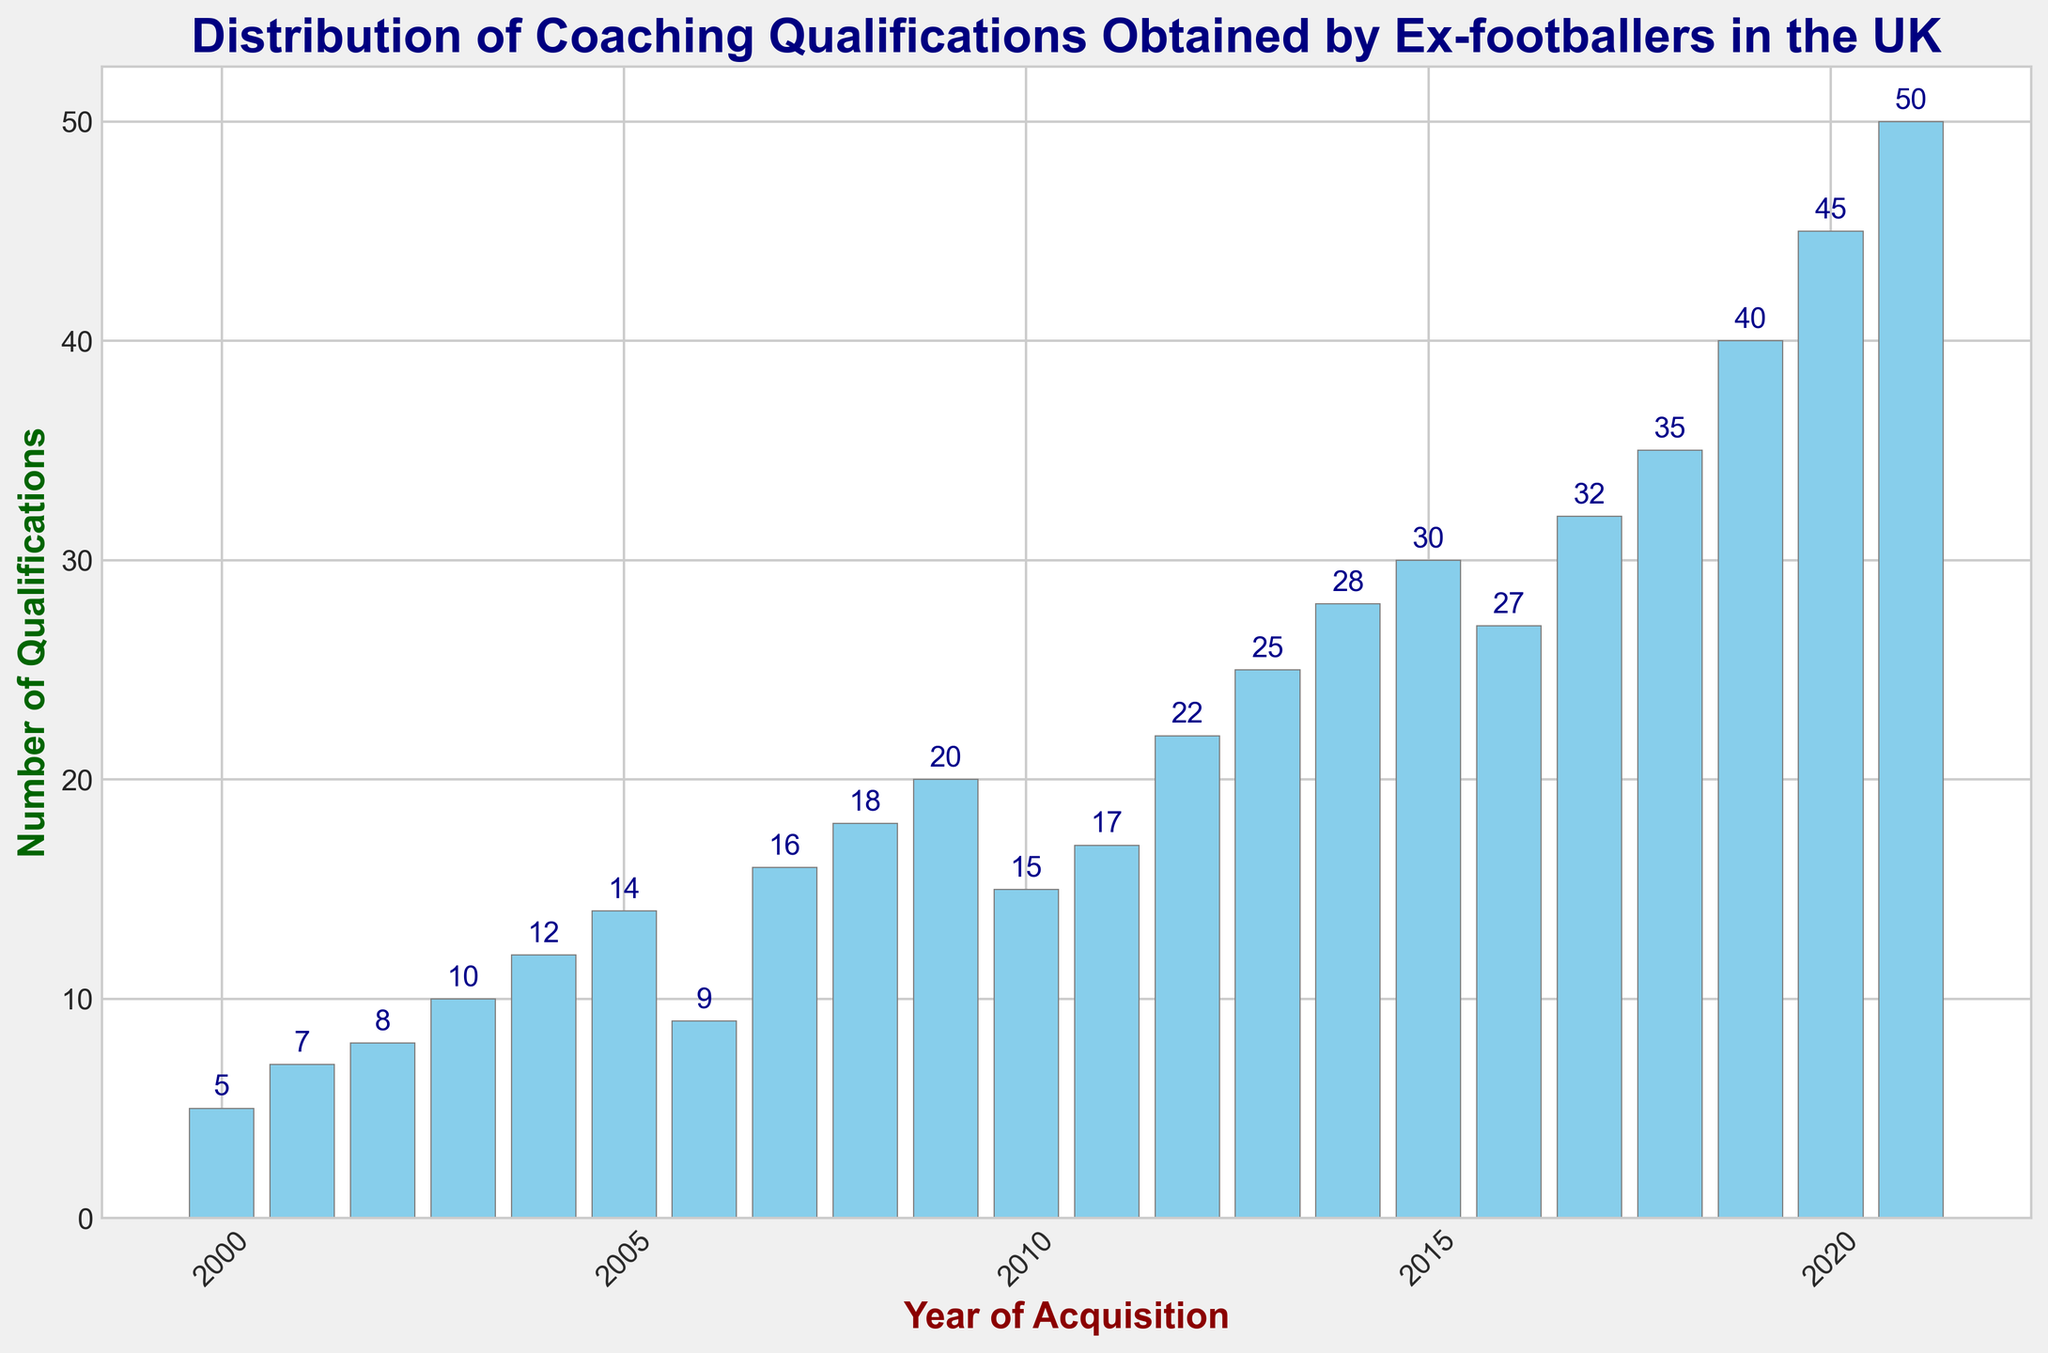What is the total number of coaching qualifications obtained from 2010 to 2020? Sum the number of qualifications from 2010 to 2020: 15 + 17 + 22 + 25 + 28 + 30 + 27 + 32 + 35 + 40 + 45 = 316
Answer: 316 Which year saw the highest number of coaching qualifications obtained? Examine the heights of all bars and identify the year with the tallest bar, which is 2021 with 50 qualifications
Answer: 2021 How does the number of qualifications in 2010 compare to that in 2019? Compare the heights of the bars for 2010 (15 qualifications) and 2019 (40 qualifications); 40 > 15
Answer: 2019 has more What is the average number of coaching qualifications obtained per year between 2000 and 2005? Calculate the average from 2000 to 2005: (5 + 7 + 8 + 10 + 12 + 14) / 6 = 56 / 6 ≈ 9.33
Answer: ≈ 9.33 Which year experienced the largest increase in the number of qualifications compared to the previous year? Calculate the year-over-year changes: 
2001-2000 = 2,
2002-2001 = 1,
2003-2002 = 2,
2004-2003 = 2,
2005-2004 = 2,
2006-2005 = -5,
2007-2006 = 7,
2008-2007 = 2,
2009-2008 = 2,
2010-2009 = -5,
2011-2010 = 2,
2012-2011 = 5,
2013-2012 = 3,
2014-2013 = 3,
2015-2014 = 2,
2016-2015 = -3,
2017-2016 = 5,
2018-2017 = 3,
2019-2018 = 5,
2020-2019 = 5,
2021-2020 = 5;
Largest increase is in 2007 with 7
Answer: 2007 Which bars are colored sky blue? All bars in the histogram are colored sky blue
Answer: All bars Was there a decrease in the number of qualifications obtained in any year compared to the previous year? Yes, check bar heights for 2006 vs. 2005 and 2010 vs. 2009 and 2016 vs. 2015. In 2006, 9 < 14; in 2010, 15 < 20; in 2016, 27 < 30
Answer: Yes Between which years did the qualifications double from one year to the next? Observing the chart, look for any year where qualifications doubled: none of the bars show such a substantial increase directly
Answer: None What is the trend observed in the number of qualifications from 2000 to 2021? The general trend shows an increase in the number of coaching qualifications over the years, with some fluctuations up and down
Answer: Increasing trend 